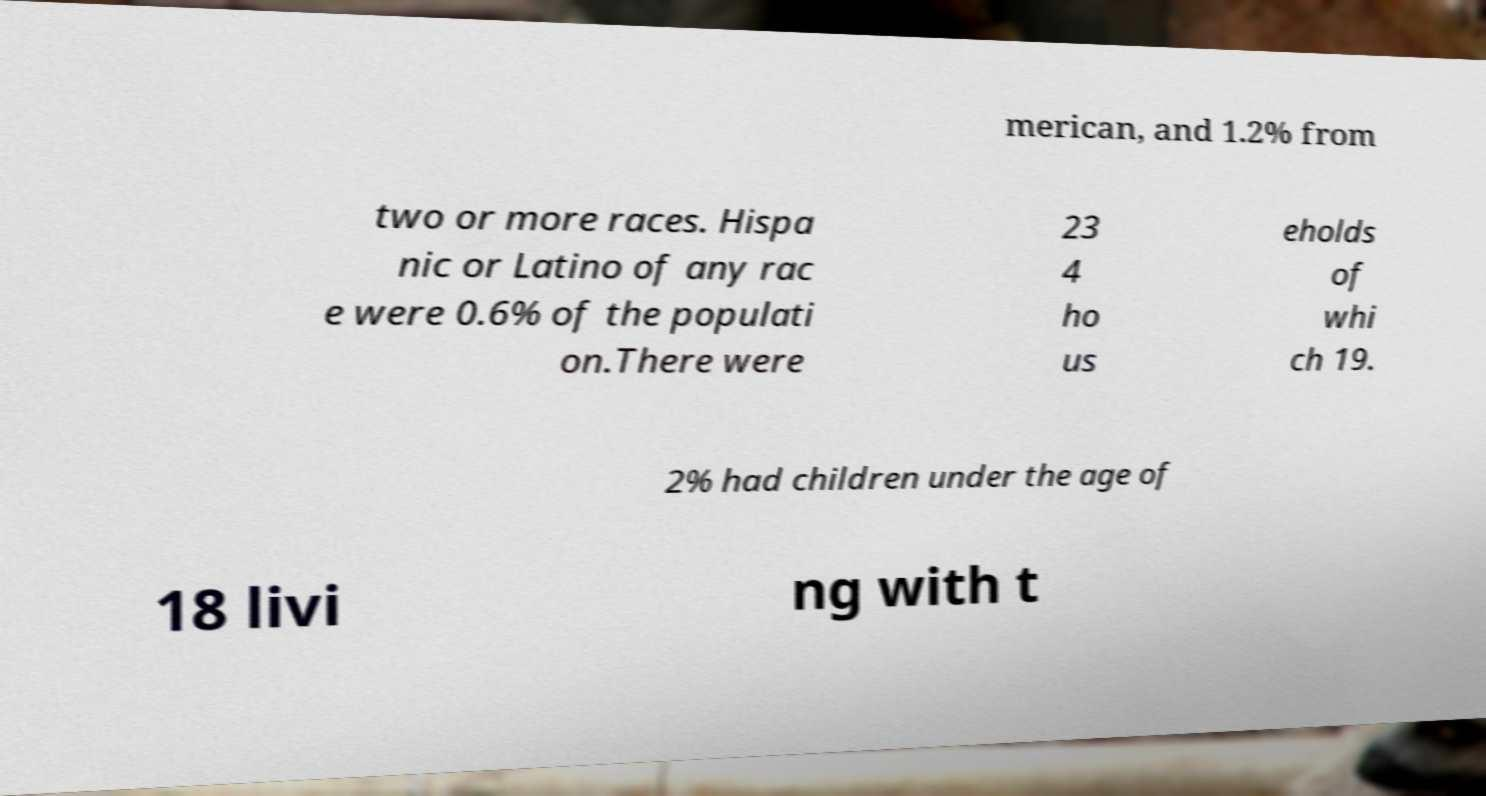What messages or text are displayed in this image? I need them in a readable, typed format. merican, and 1.2% from two or more races. Hispa nic or Latino of any rac e were 0.6% of the populati on.There were 23 4 ho us eholds of whi ch 19. 2% had children under the age of 18 livi ng with t 